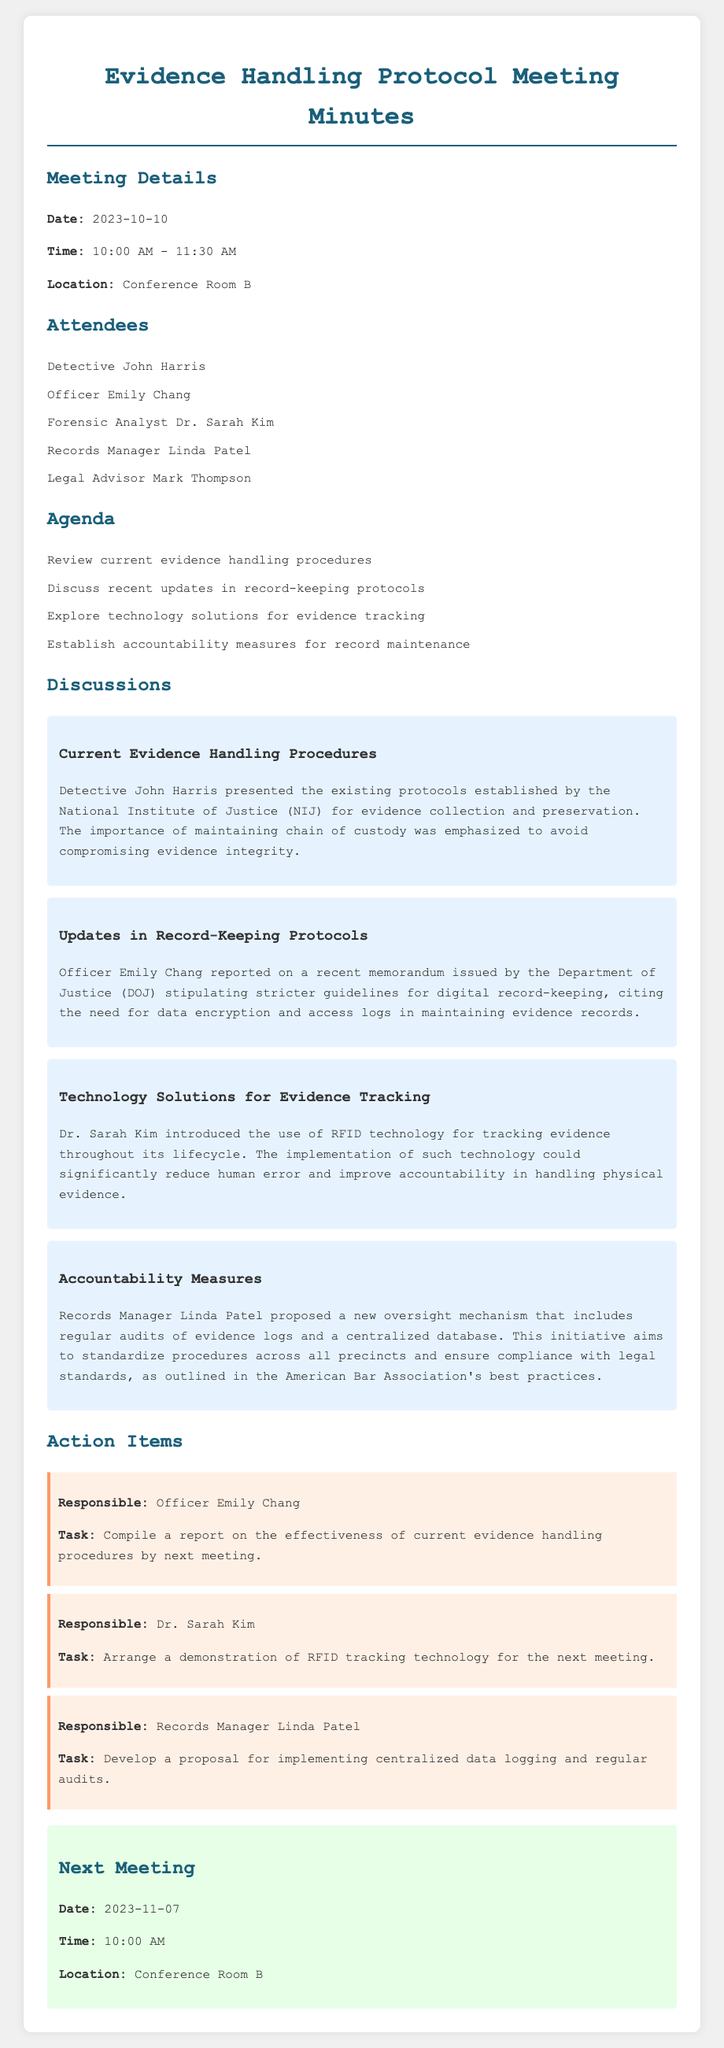What is the date of the meeting? The date of the meeting is explicitly stated in the document under "Meeting Details" as 2023-10-10.
Answer: 2023-10-10 Who presented the current evidence handling procedures? The document states that Detective John Harris presented the current evidence handling procedures during the meeting discussion.
Answer: Detective John Harris What technology was introduced for evidence tracking? Dr. Sarah Kim introduced RFID technology for tracking evidence, as mentioned in the discussions.
Answer: RFID technology What is the next meeting date? The next meeting date is provided in the document under "Next Meeting" as 2023-11-07.
Answer: 2023-11-07 Who is responsible for compiling a report on current evidence handling procedures? The document lists Officer Emily Chang as responsible for compiling the report on current evidence handling procedures.
Answer: Officer Emily Chang What is the main focus of the updates in record-keeping protocols? The updates in record-keeping are focused on stricter guidelines for digital record-keeping, specifically mentioning data encryption and access logs.
Answer: Stricter guidelines for digital record-keeping How does Linda Patel propose to ensure compliance with legal standards? The proposal includes regular audits of evidence logs and a centralized database to ensure compliance with legal standards.
Answer: Regular audits and centralized database What was the main emphasis of Detective John Harris's discussion? The emphasis was on maintaining the chain of custody to avoid compromising evidence integrity, which was highlighted in the discussions.
Answer: Maintaining chain of custody 